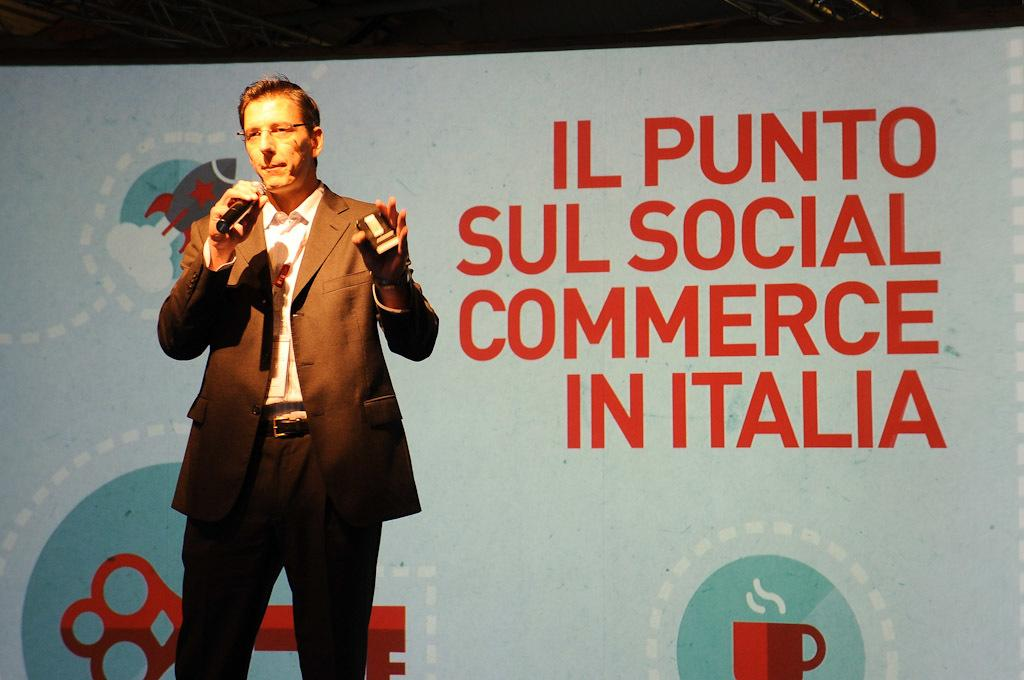What is the person in the image doing? The person is standing in the image and holding a mic. What else is the person holding in the image? The person is holding another object in both hands. What can be seen behind the person in the image? There is a banner with text behind the person. What type of veil is draped over the person's head in the image? There is no veil present in the image. What kind of glove is the person wearing on their hands while holding the object? There is no glove visible in the image; the person is holding the object with both hands. 